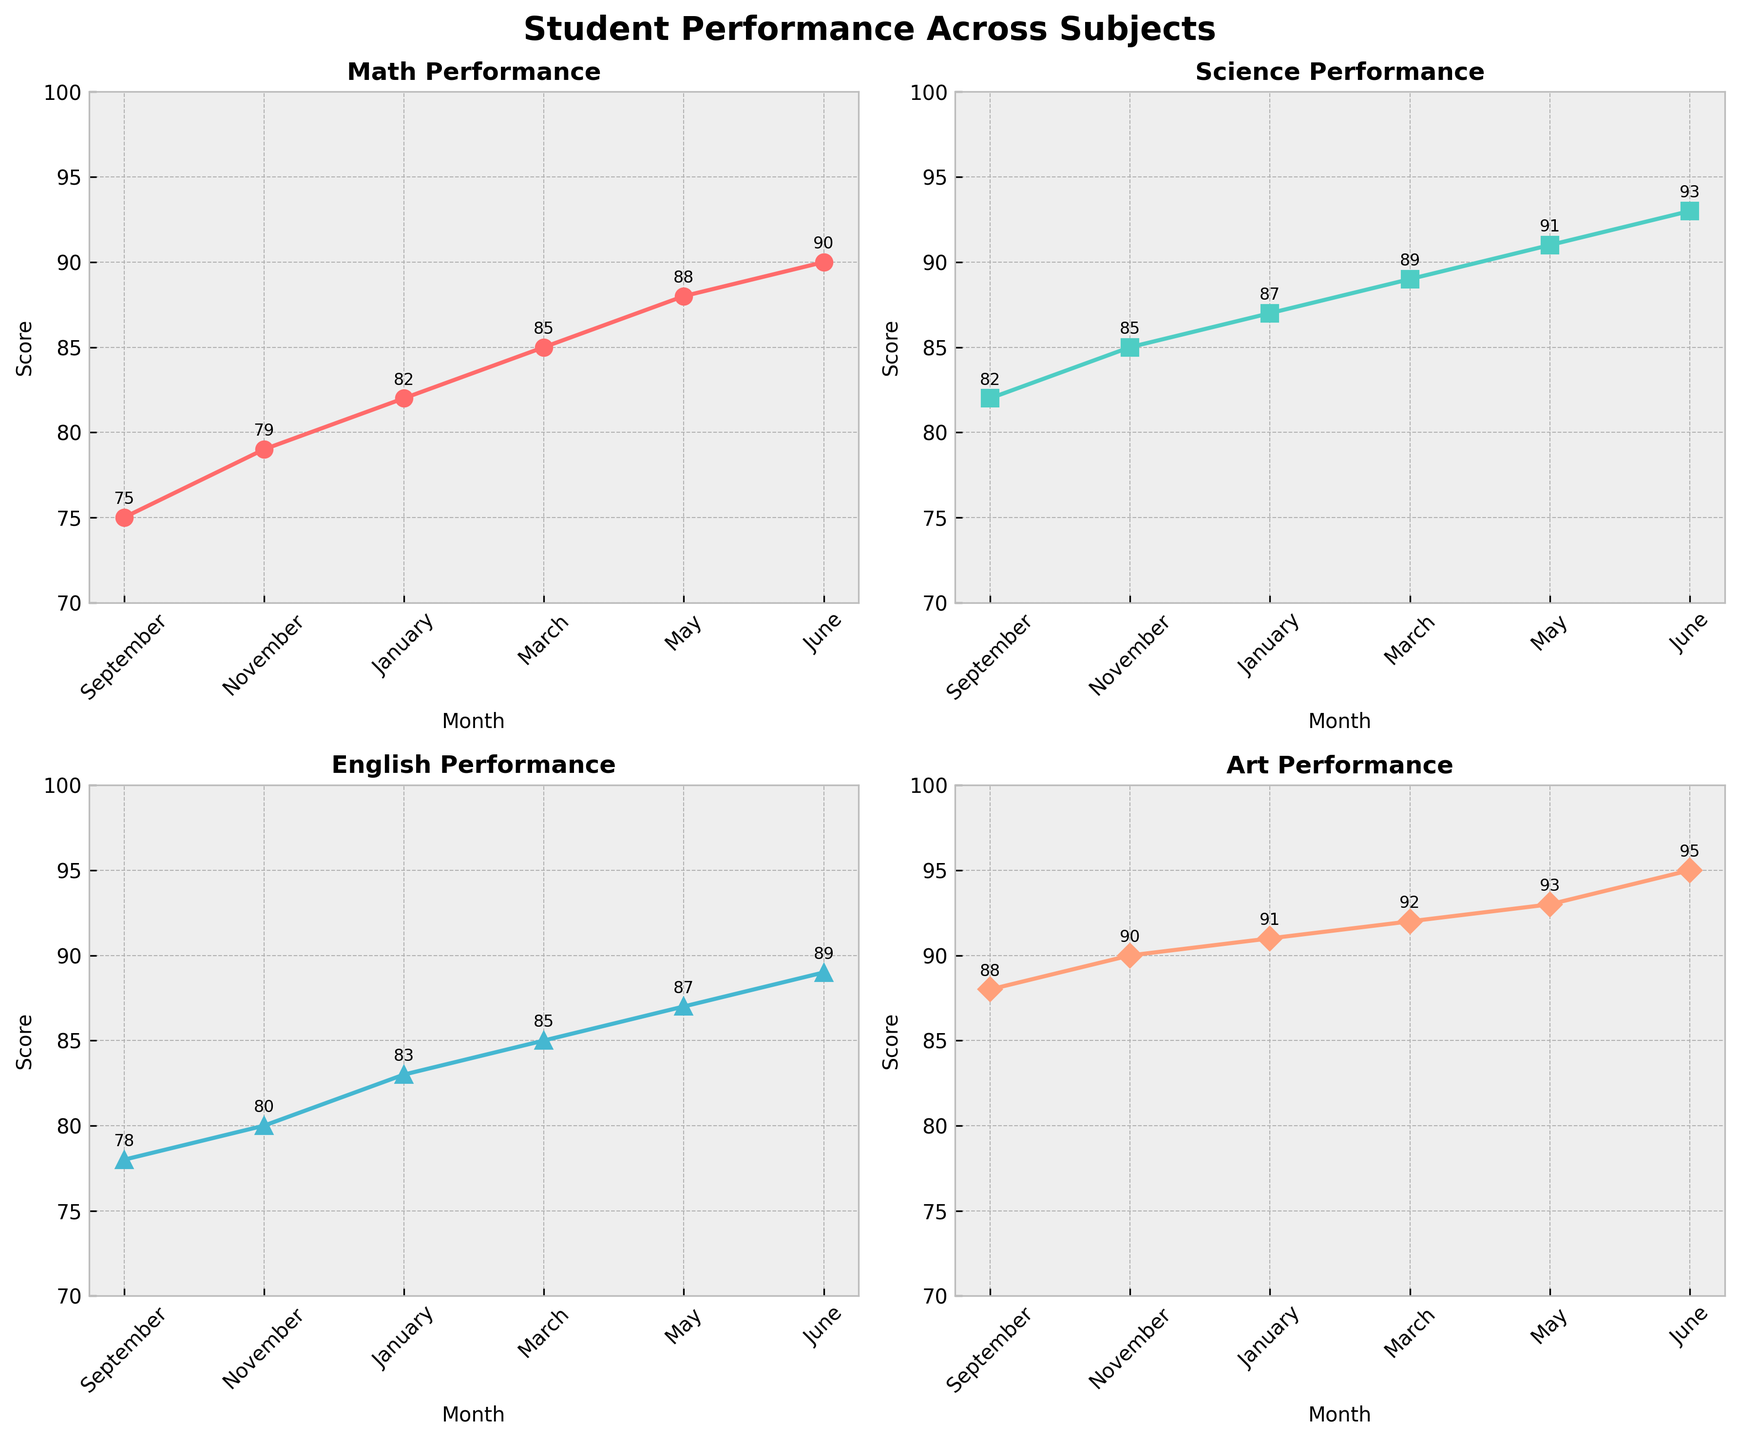what's the title of the figure? The figure's title is located at the top center and is typically the prominent text in bold. In this plot, based on the code provided, the title is "Student Performance Across Subjects".
Answer: Student Performance Across Subjects How many subjects are represented in the subplots? Each subplot represents a different subject the students are evaluated in. There are 4 subplots, each with its own title specifying the subject.
Answer: 4 Which subject showed the highest score by June? To determine the highest score by June, we look at the annotations for the June data point in each subplot. Math scored 90, Science 93, English 89, and Art 95. Art has the highest score.
Answer: Art What's the difference between the highest and lowest scores in English over the school year? Identify the highest and lowest scores in the English subplot: the highest is 89 (June) and the lowest is 78 (September). The difference can be calculated as 89 - 78.
Answer: 11 What’s the average score of Math in the school year? The scores for Math are 75, 79, 82, 85, 88, and 90. Summing these scores gives 499. Dividing by the number of observations (6) gives 499 / 6.
Answer: 83.17 How did the Science scores change from January to March? In the Science subplot, the score in January is 87, and in March, it's 89. The change is calculated as 89 - 87.
Answer: Increased by 2 In which month did English and Art have the same score? By examining the annotations closely, we compare the scores of English and Art in each month and find they both have a score of 92 in March.
Answer: March Which subject shows the steepest upward trend from September to June? By comparing the slopes of the lines in each subplot from September to June, we see that while all subjects show upward trends, Art moves from 88 to 95, which is a total increase of 7.
Answer: Art How do the variances of Math and Science scores compare throughout the school year? The scores for Math are 75, 79, 82, 85, 88, and 90, while the scores for Science are 82, 85, 87, 89, 91, and 93. Calculate the variance for each and compare them. However, visually it's clear that the range for Science scores is smaller (82 to 93) compared to Math (75 to 90).
Answer: Math has higher variance What is the general trend observed in all subjects' performance over the school year? By looking at the lines in each subplot, we observe that each line has a positive slope, indicating that the scores for all subjects generally increased over the school year.
Answer: Increasing trend 